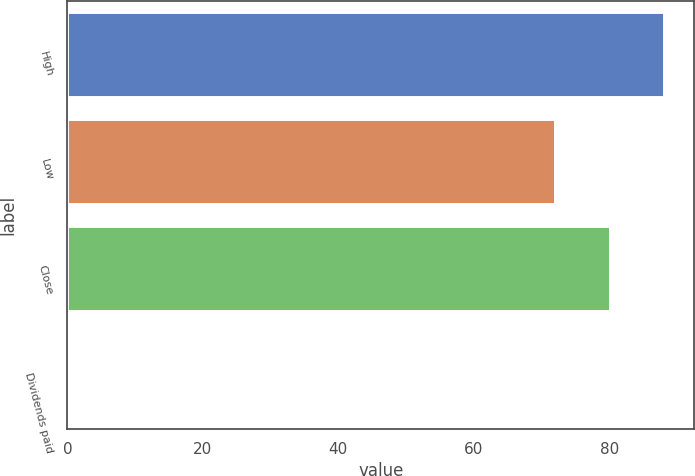Convert chart. <chart><loc_0><loc_0><loc_500><loc_500><bar_chart><fcel>High<fcel>Low<fcel>Close<fcel>Dividends paid<nl><fcel>88.12<fcel>71.96<fcel>80.04<fcel>0.25<nl></chart> 